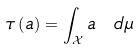<formula> <loc_0><loc_0><loc_500><loc_500>\tau \left ( a \right ) = \int _ { \mathcal { X } } a \ d \mu</formula> 